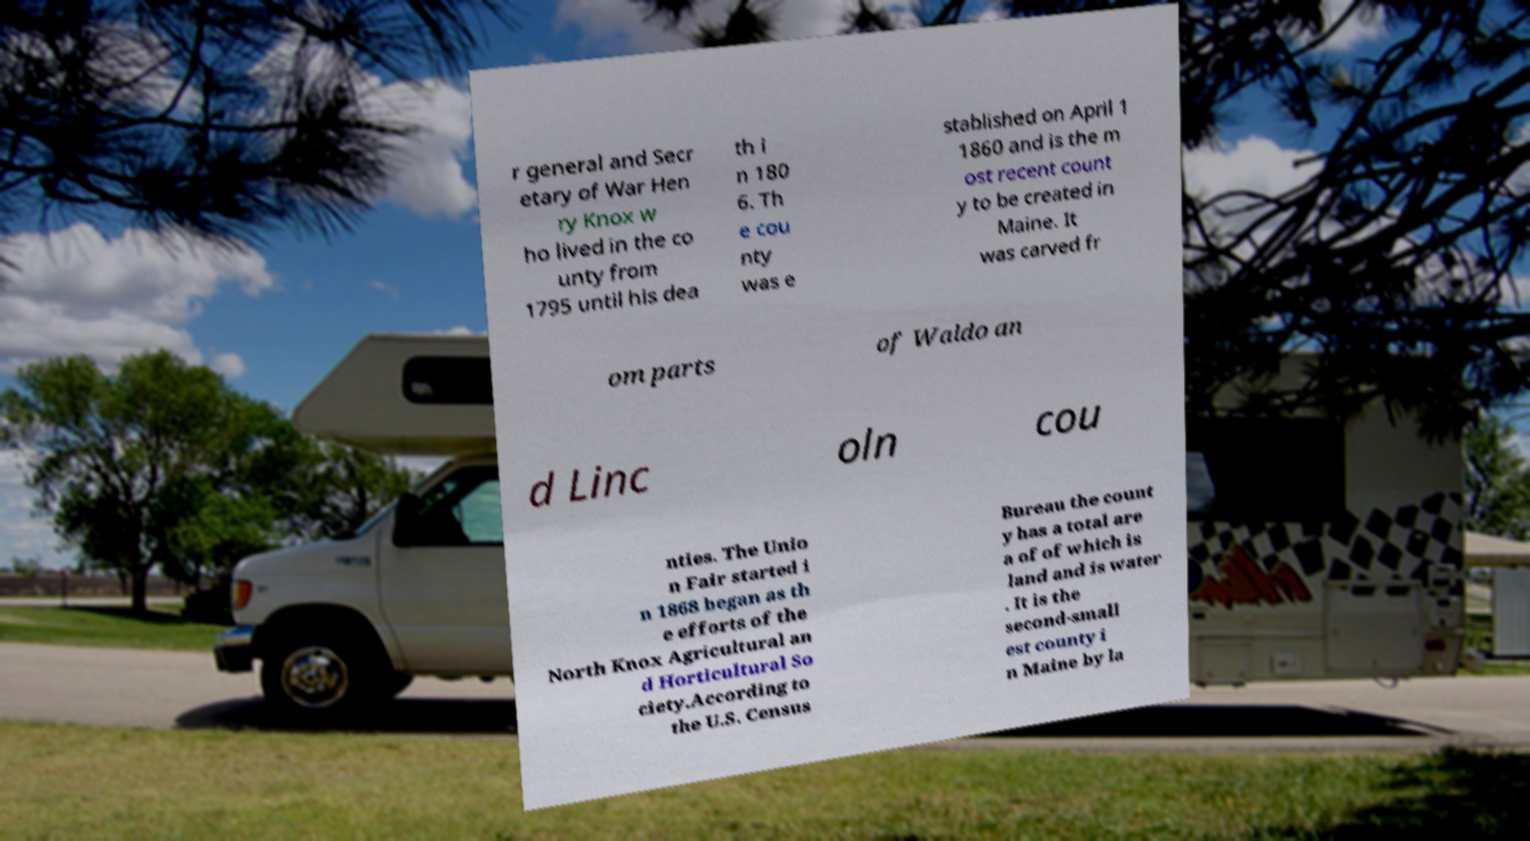Can you read and provide the text displayed in the image?This photo seems to have some interesting text. Can you extract and type it out for me? r general and Secr etary of War Hen ry Knox w ho lived in the co unty from 1795 until his dea th i n 180 6. Th e cou nty was e stablished on April 1 1860 and is the m ost recent count y to be created in Maine. It was carved fr om parts of Waldo an d Linc oln cou nties. The Unio n Fair started i n 1868 began as th e efforts of the North Knox Agricultural an d Horticultural So ciety.According to the U.S. Census Bureau the count y has a total are a of of which is land and is water . It is the second-small est county i n Maine by la 